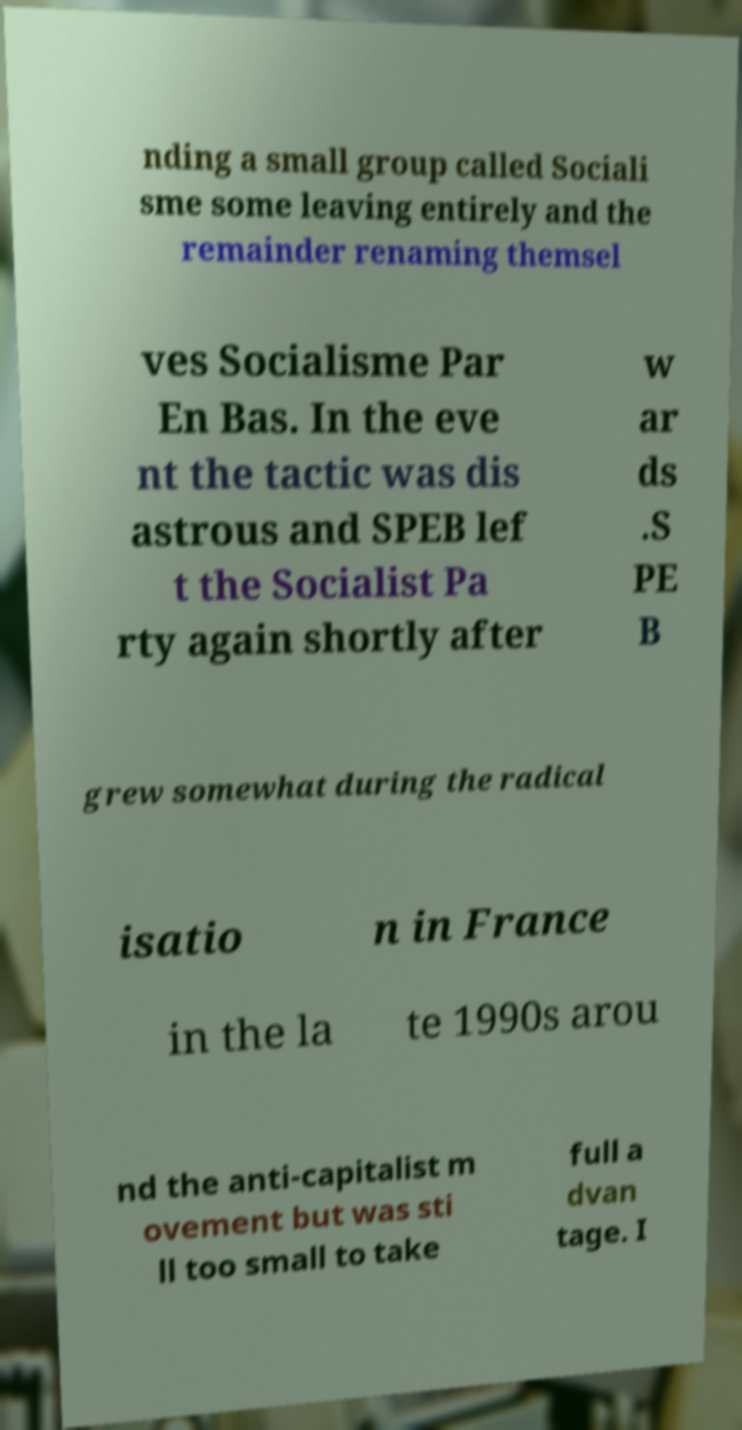Can you read and provide the text displayed in the image?This photo seems to have some interesting text. Can you extract and type it out for me? nding a small group called Sociali sme some leaving entirely and the remainder renaming themsel ves Socialisme Par En Bas. In the eve nt the tactic was dis astrous and SPEB lef t the Socialist Pa rty again shortly after w ar ds .S PE B grew somewhat during the radical isatio n in France in the la te 1990s arou nd the anti-capitalist m ovement but was sti ll too small to take full a dvan tage. I 